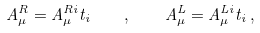Convert formula to latex. <formula><loc_0><loc_0><loc_500><loc_500>A ^ { R } _ { \mu } = A ^ { R i } _ { \mu } t _ { i } \quad , \quad A ^ { L } _ { \mu } = A ^ { L i } _ { \mu } t _ { i } \, ,</formula> 